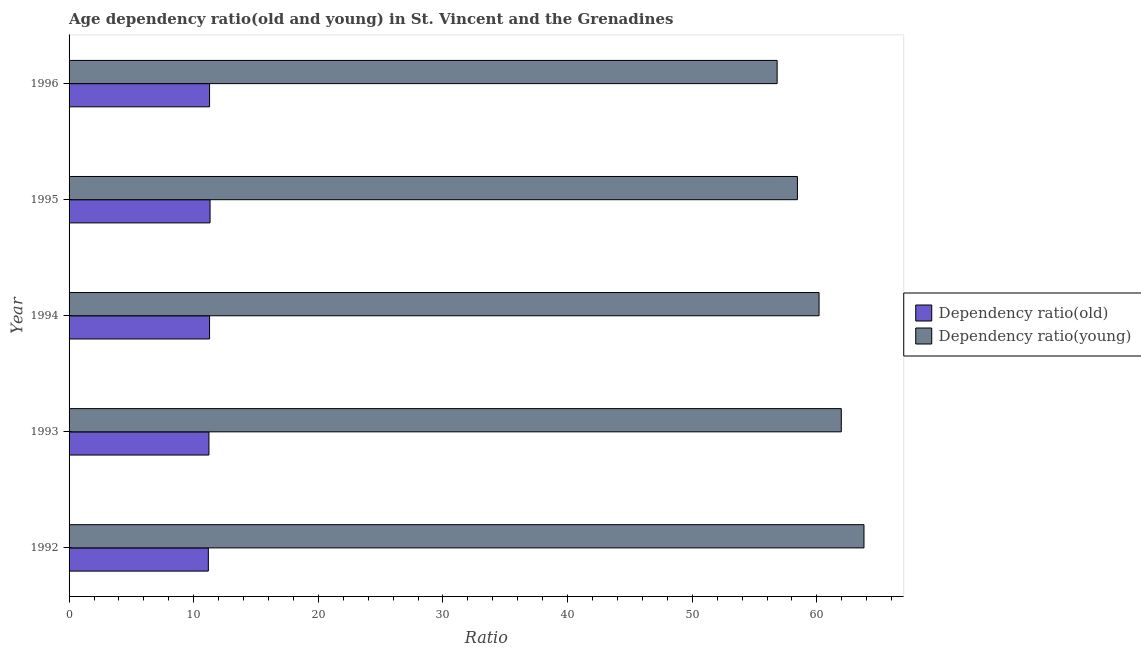How many different coloured bars are there?
Keep it short and to the point. 2. Are the number of bars per tick equal to the number of legend labels?
Offer a very short reply. Yes. What is the label of the 3rd group of bars from the top?
Your answer should be very brief. 1994. What is the age dependency ratio(old) in 1993?
Your answer should be compact. 11.22. Across all years, what is the maximum age dependency ratio(young)?
Your answer should be compact. 63.78. Across all years, what is the minimum age dependency ratio(young)?
Make the answer very short. 56.81. In which year was the age dependency ratio(young) maximum?
Your answer should be compact. 1992. In which year was the age dependency ratio(old) minimum?
Make the answer very short. 1992. What is the total age dependency ratio(old) in the graph?
Your answer should be very brief. 56.25. What is the difference between the age dependency ratio(young) in 1992 and that in 1996?
Your response must be concise. 6.97. What is the difference between the age dependency ratio(young) in 1995 and the age dependency ratio(old) in 1993?
Give a very brief answer. 47.21. What is the average age dependency ratio(young) per year?
Provide a succinct answer. 60.23. In the year 1992, what is the difference between the age dependency ratio(young) and age dependency ratio(old)?
Ensure brevity in your answer.  52.6. What is the ratio of the age dependency ratio(old) in 1993 to that in 1995?
Your response must be concise. 0.99. Is the age dependency ratio(old) in 1992 less than that in 1995?
Provide a short and direct response. Yes. Is the difference between the age dependency ratio(old) in 1994 and 1995 greater than the difference between the age dependency ratio(young) in 1994 and 1995?
Offer a very short reply. No. What is the difference between the highest and the second highest age dependency ratio(old)?
Make the answer very short. 0.04. What is the difference between the highest and the lowest age dependency ratio(young)?
Keep it short and to the point. 6.97. In how many years, is the age dependency ratio(old) greater than the average age dependency ratio(old) taken over all years?
Your answer should be compact. 3. Is the sum of the age dependency ratio(young) in 1993 and 1994 greater than the maximum age dependency ratio(old) across all years?
Provide a short and direct response. Yes. What does the 2nd bar from the top in 1994 represents?
Your response must be concise. Dependency ratio(old). What does the 2nd bar from the bottom in 1992 represents?
Keep it short and to the point. Dependency ratio(young). How many years are there in the graph?
Ensure brevity in your answer.  5. What is the difference between two consecutive major ticks on the X-axis?
Ensure brevity in your answer.  10. Does the graph contain any zero values?
Your answer should be compact. No. Does the graph contain grids?
Offer a terse response. No. How are the legend labels stacked?
Your answer should be compact. Vertical. What is the title of the graph?
Offer a very short reply. Age dependency ratio(old and young) in St. Vincent and the Grenadines. What is the label or title of the X-axis?
Offer a very short reply. Ratio. What is the label or title of the Y-axis?
Your answer should be compact. Year. What is the Ratio of Dependency ratio(old) in 1992?
Offer a very short reply. 11.17. What is the Ratio of Dependency ratio(young) in 1992?
Provide a succinct answer. 63.78. What is the Ratio in Dependency ratio(old) in 1993?
Provide a short and direct response. 11.22. What is the Ratio of Dependency ratio(young) in 1993?
Provide a succinct answer. 61.96. What is the Ratio of Dependency ratio(old) in 1994?
Keep it short and to the point. 11.27. What is the Ratio in Dependency ratio(young) in 1994?
Make the answer very short. 60.17. What is the Ratio of Dependency ratio(old) in 1995?
Your answer should be very brief. 11.31. What is the Ratio of Dependency ratio(young) in 1995?
Provide a short and direct response. 58.44. What is the Ratio in Dependency ratio(old) in 1996?
Offer a very short reply. 11.27. What is the Ratio in Dependency ratio(young) in 1996?
Your response must be concise. 56.81. Across all years, what is the maximum Ratio in Dependency ratio(old)?
Offer a very short reply. 11.31. Across all years, what is the maximum Ratio in Dependency ratio(young)?
Provide a succinct answer. 63.78. Across all years, what is the minimum Ratio in Dependency ratio(old)?
Offer a very short reply. 11.17. Across all years, what is the minimum Ratio in Dependency ratio(young)?
Offer a very short reply. 56.81. What is the total Ratio of Dependency ratio(old) in the graph?
Keep it short and to the point. 56.25. What is the total Ratio of Dependency ratio(young) in the graph?
Keep it short and to the point. 301.15. What is the difference between the Ratio in Dependency ratio(old) in 1992 and that in 1993?
Ensure brevity in your answer.  -0.05. What is the difference between the Ratio of Dependency ratio(young) in 1992 and that in 1993?
Offer a terse response. 1.82. What is the difference between the Ratio of Dependency ratio(old) in 1992 and that in 1994?
Your answer should be very brief. -0.1. What is the difference between the Ratio in Dependency ratio(young) in 1992 and that in 1994?
Your response must be concise. 3.6. What is the difference between the Ratio of Dependency ratio(old) in 1992 and that in 1995?
Offer a terse response. -0.14. What is the difference between the Ratio in Dependency ratio(young) in 1992 and that in 1995?
Make the answer very short. 5.34. What is the difference between the Ratio in Dependency ratio(old) in 1992 and that in 1996?
Provide a short and direct response. -0.1. What is the difference between the Ratio in Dependency ratio(young) in 1992 and that in 1996?
Provide a succinct answer. 6.97. What is the difference between the Ratio of Dependency ratio(old) in 1993 and that in 1994?
Your response must be concise. -0.05. What is the difference between the Ratio in Dependency ratio(young) in 1993 and that in 1994?
Ensure brevity in your answer.  1.78. What is the difference between the Ratio in Dependency ratio(old) in 1993 and that in 1995?
Keep it short and to the point. -0.09. What is the difference between the Ratio in Dependency ratio(young) in 1993 and that in 1995?
Ensure brevity in your answer.  3.52. What is the difference between the Ratio in Dependency ratio(old) in 1993 and that in 1996?
Offer a very short reply. -0.05. What is the difference between the Ratio of Dependency ratio(young) in 1993 and that in 1996?
Make the answer very short. 5.15. What is the difference between the Ratio of Dependency ratio(old) in 1994 and that in 1995?
Keep it short and to the point. -0.04. What is the difference between the Ratio of Dependency ratio(young) in 1994 and that in 1995?
Provide a succinct answer. 1.74. What is the difference between the Ratio in Dependency ratio(old) in 1994 and that in 1996?
Your response must be concise. -0. What is the difference between the Ratio of Dependency ratio(young) in 1994 and that in 1996?
Your answer should be compact. 3.36. What is the difference between the Ratio in Dependency ratio(old) in 1995 and that in 1996?
Make the answer very short. 0.04. What is the difference between the Ratio of Dependency ratio(young) in 1995 and that in 1996?
Ensure brevity in your answer.  1.63. What is the difference between the Ratio in Dependency ratio(old) in 1992 and the Ratio in Dependency ratio(young) in 1993?
Offer a very short reply. -50.78. What is the difference between the Ratio of Dependency ratio(old) in 1992 and the Ratio of Dependency ratio(young) in 1994?
Make the answer very short. -49. What is the difference between the Ratio in Dependency ratio(old) in 1992 and the Ratio in Dependency ratio(young) in 1995?
Provide a short and direct response. -47.26. What is the difference between the Ratio in Dependency ratio(old) in 1992 and the Ratio in Dependency ratio(young) in 1996?
Provide a short and direct response. -45.64. What is the difference between the Ratio of Dependency ratio(old) in 1993 and the Ratio of Dependency ratio(young) in 1994?
Give a very brief answer. -48.95. What is the difference between the Ratio of Dependency ratio(old) in 1993 and the Ratio of Dependency ratio(young) in 1995?
Provide a short and direct response. -47.21. What is the difference between the Ratio in Dependency ratio(old) in 1993 and the Ratio in Dependency ratio(young) in 1996?
Keep it short and to the point. -45.59. What is the difference between the Ratio of Dependency ratio(old) in 1994 and the Ratio of Dependency ratio(young) in 1995?
Your response must be concise. -47.16. What is the difference between the Ratio in Dependency ratio(old) in 1994 and the Ratio in Dependency ratio(young) in 1996?
Provide a short and direct response. -45.54. What is the difference between the Ratio in Dependency ratio(old) in 1995 and the Ratio in Dependency ratio(young) in 1996?
Keep it short and to the point. -45.5. What is the average Ratio in Dependency ratio(old) per year?
Your response must be concise. 11.25. What is the average Ratio of Dependency ratio(young) per year?
Offer a very short reply. 60.23. In the year 1992, what is the difference between the Ratio in Dependency ratio(old) and Ratio in Dependency ratio(young)?
Make the answer very short. -52.6. In the year 1993, what is the difference between the Ratio in Dependency ratio(old) and Ratio in Dependency ratio(young)?
Ensure brevity in your answer.  -50.73. In the year 1994, what is the difference between the Ratio in Dependency ratio(old) and Ratio in Dependency ratio(young)?
Your answer should be compact. -48.9. In the year 1995, what is the difference between the Ratio of Dependency ratio(old) and Ratio of Dependency ratio(young)?
Offer a terse response. -47.12. In the year 1996, what is the difference between the Ratio of Dependency ratio(old) and Ratio of Dependency ratio(young)?
Give a very brief answer. -45.54. What is the ratio of the Ratio of Dependency ratio(old) in 1992 to that in 1993?
Your response must be concise. 1. What is the ratio of the Ratio of Dependency ratio(young) in 1992 to that in 1993?
Offer a terse response. 1.03. What is the ratio of the Ratio in Dependency ratio(old) in 1992 to that in 1994?
Provide a short and direct response. 0.99. What is the ratio of the Ratio in Dependency ratio(young) in 1992 to that in 1994?
Your answer should be very brief. 1.06. What is the ratio of the Ratio of Dependency ratio(old) in 1992 to that in 1995?
Offer a very short reply. 0.99. What is the ratio of the Ratio of Dependency ratio(young) in 1992 to that in 1995?
Ensure brevity in your answer.  1.09. What is the ratio of the Ratio of Dependency ratio(old) in 1992 to that in 1996?
Offer a terse response. 0.99. What is the ratio of the Ratio in Dependency ratio(young) in 1992 to that in 1996?
Give a very brief answer. 1.12. What is the ratio of the Ratio in Dependency ratio(young) in 1993 to that in 1994?
Ensure brevity in your answer.  1.03. What is the ratio of the Ratio in Dependency ratio(young) in 1993 to that in 1995?
Your response must be concise. 1.06. What is the ratio of the Ratio of Dependency ratio(young) in 1993 to that in 1996?
Your response must be concise. 1.09. What is the ratio of the Ratio in Dependency ratio(young) in 1994 to that in 1995?
Keep it short and to the point. 1.03. What is the ratio of the Ratio of Dependency ratio(old) in 1994 to that in 1996?
Offer a very short reply. 1. What is the ratio of the Ratio of Dependency ratio(young) in 1994 to that in 1996?
Offer a very short reply. 1.06. What is the ratio of the Ratio of Dependency ratio(old) in 1995 to that in 1996?
Keep it short and to the point. 1. What is the ratio of the Ratio in Dependency ratio(young) in 1995 to that in 1996?
Your answer should be very brief. 1.03. What is the difference between the highest and the second highest Ratio in Dependency ratio(old)?
Your answer should be very brief. 0.04. What is the difference between the highest and the second highest Ratio in Dependency ratio(young)?
Offer a very short reply. 1.82. What is the difference between the highest and the lowest Ratio in Dependency ratio(old)?
Offer a terse response. 0.14. What is the difference between the highest and the lowest Ratio of Dependency ratio(young)?
Provide a succinct answer. 6.97. 